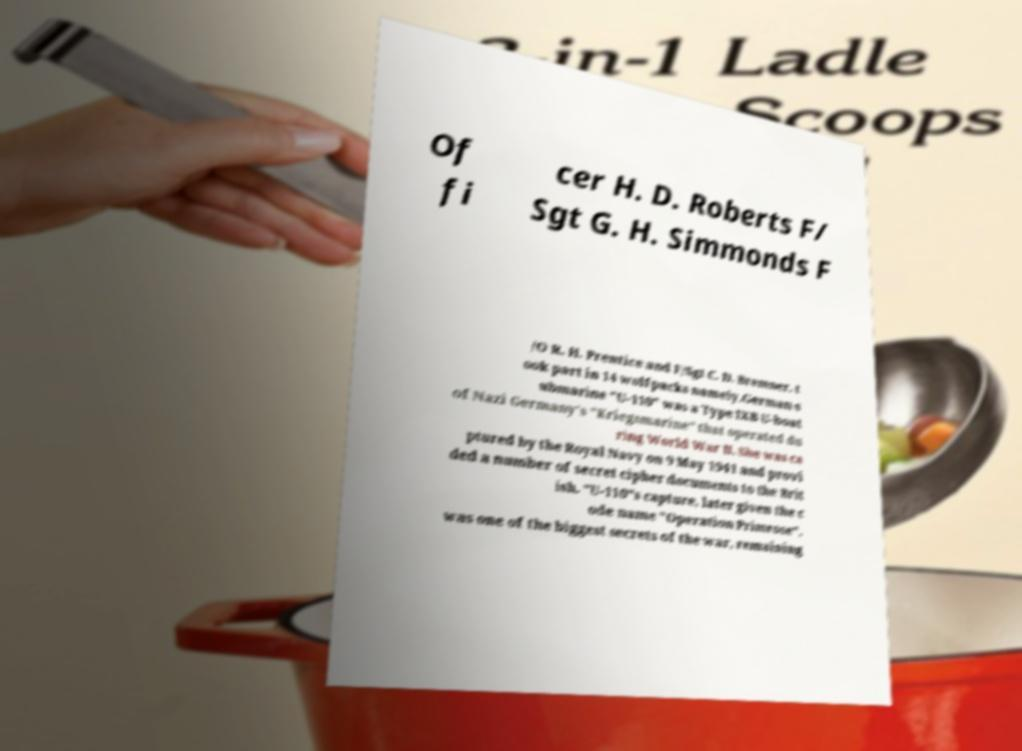Please identify and transcribe the text found in this image. Of fi cer H. D. Roberts F/ Sgt G. H. Simmonds F /O R. H. Prentice and F/Sgt C. D. Bremner. t ook part in 14 wolfpacks namely.German s ubmarine "U-110" was a Type IXB U-boat of Nazi Germany's "Kriegsmarine" that operated du ring World War II. She was ca ptured by the Royal Navy on 9 May 1941 and provi ded a number of secret cipher documents to the Brit ish. "U-110"s capture, later given the c ode name "Operation Primrose", was one of the biggest secrets of the war, remaining 